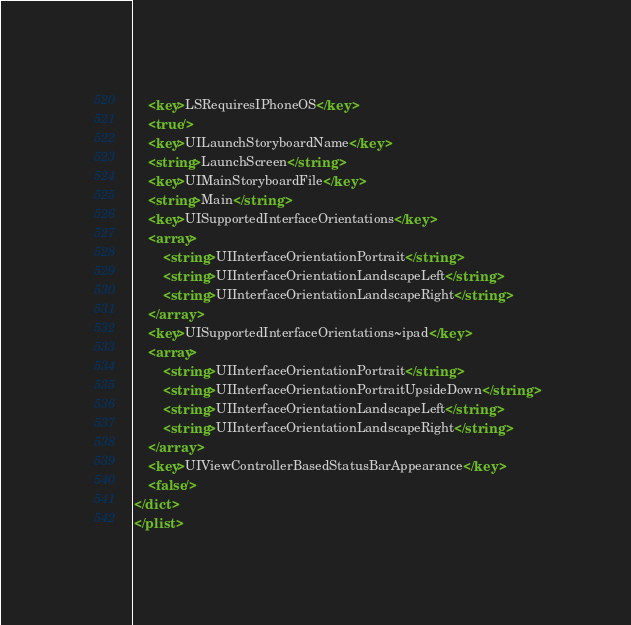Convert code to text. <code><loc_0><loc_0><loc_500><loc_500><_XML_>	<key>LSRequiresIPhoneOS</key>
	<true/>
	<key>UILaunchStoryboardName</key>
	<string>LaunchScreen</string>
	<key>UIMainStoryboardFile</key>
	<string>Main</string>
	<key>UISupportedInterfaceOrientations</key>
	<array>
		<string>UIInterfaceOrientationPortrait</string>
		<string>UIInterfaceOrientationLandscapeLeft</string>
		<string>UIInterfaceOrientationLandscapeRight</string>
	</array>
	<key>UISupportedInterfaceOrientations~ipad</key>
	<array>
		<string>UIInterfaceOrientationPortrait</string>
		<string>UIInterfaceOrientationPortraitUpsideDown</string>
		<string>UIInterfaceOrientationLandscapeLeft</string>
		<string>UIInterfaceOrientationLandscapeRight</string>
	</array>
	<key>UIViewControllerBasedStatusBarAppearance</key>
	<false/>
</dict>
</plist>
</code> 